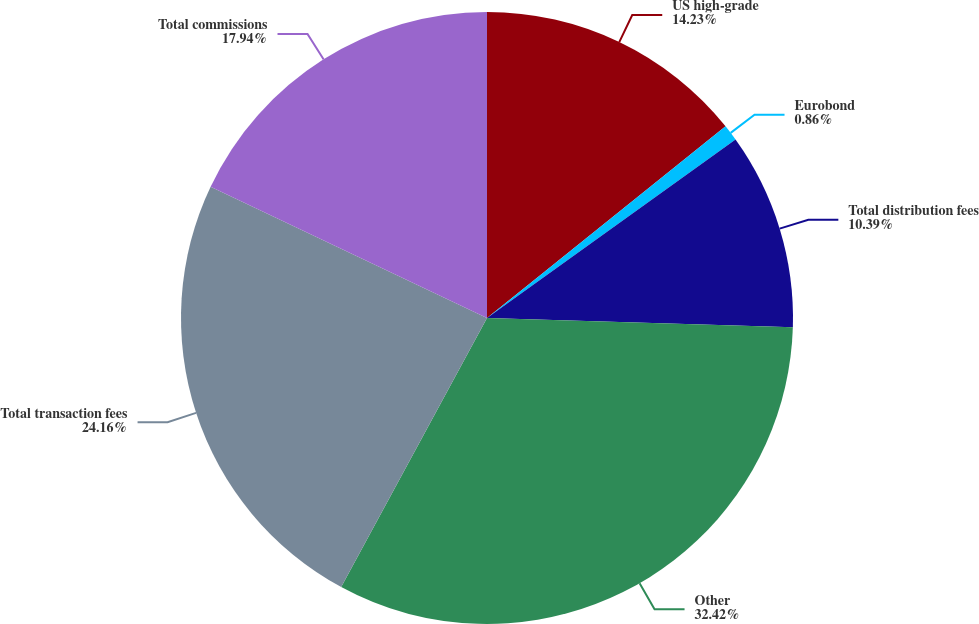Convert chart. <chart><loc_0><loc_0><loc_500><loc_500><pie_chart><fcel>US high-grade<fcel>Eurobond<fcel>Total distribution fees<fcel>Other<fcel>Total transaction fees<fcel>Total commissions<nl><fcel>14.23%<fcel>0.86%<fcel>10.39%<fcel>32.43%<fcel>24.16%<fcel>17.94%<nl></chart> 